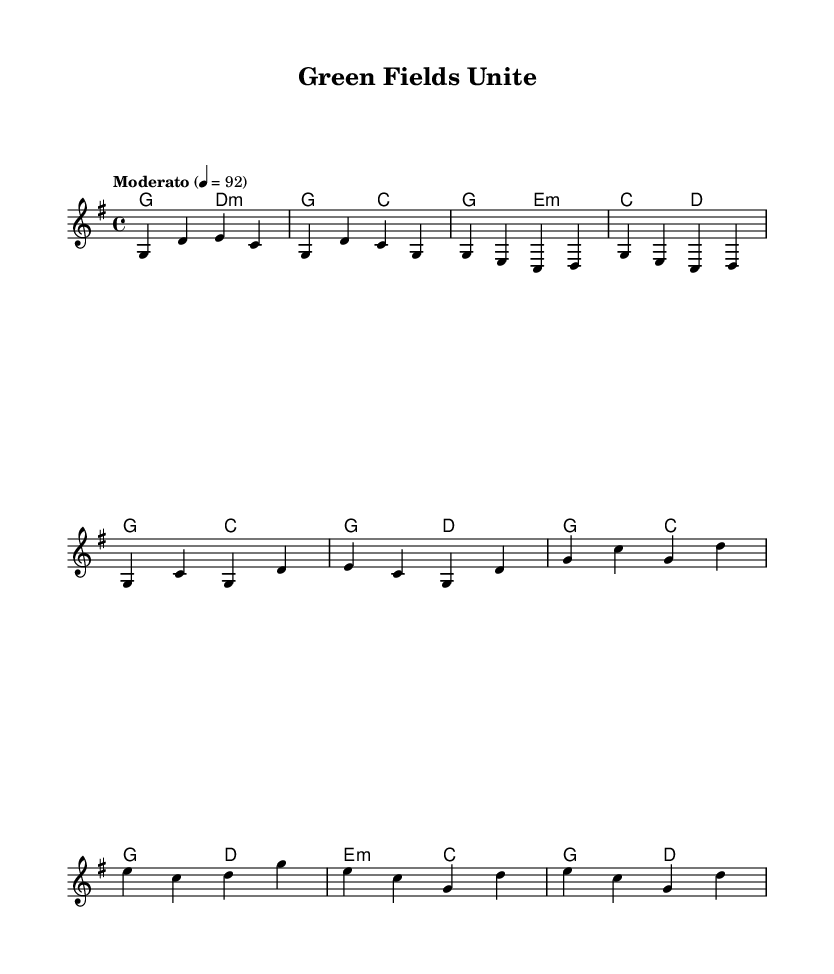What is the key signature of this music? The key signature is G major, which has one sharp (F#). This can be determined from the global settings in the code where it specifies the key signature as "g".
Answer: G major What is the time signature of this music? The time signature is 4/4, indicating four beats per measure with a quarter note getting one beat. This information is found in the global settings where the value is explicitly stated as "4/4".
Answer: 4/4 What is the tempo marking for the piece? The tempo marking is Moderato, set to a metronome marking of 92 beats per minute. This can be seen in the global section where it specifies "Moderato" and the corresponding tempo.
Answer: Moderato How many sections are in the music? The music consists of three main sections: Intro, Verse, and Chorus, along with a Bridge. The layout clearly shows different parts divided by their roles in the song.
Answer: Four What is the final chord in the score? The final chord in the score is a G major. This can be identified by examining the harmony section where it ends with the chord "g" right before the closing statement in the string of chord changes.
Answer: G major What is the relationship between the verse and chorus in terms of melody? The verse melody begins with G and E notes, while the chorus intensifies with broader note ranges including C and D, creating a contrast between the two. This reasoning is based on the differentiation in melody lines represented in the music and the harmonies provided.
Answer: Contrast 